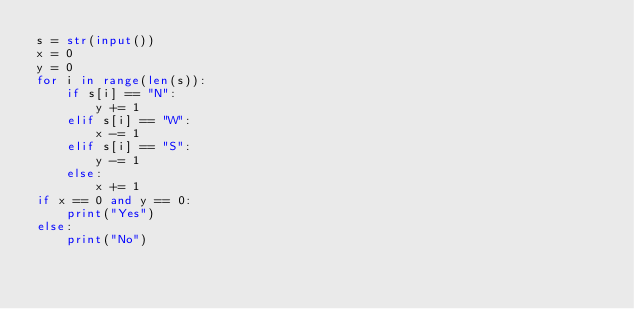Convert code to text. <code><loc_0><loc_0><loc_500><loc_500><_Python_>s = str(input())
x = 0
y = 0
for i in range(len(s)):
    if s[i] == "N":
        y += 1
    elif s[i] == "W":
        x -= 1
    elif s[i] == "S":
        y -= 1
    else:
        x += 1
if x == 0 and y == 0:
    print("Yes")
else:
    print("No")</code> 